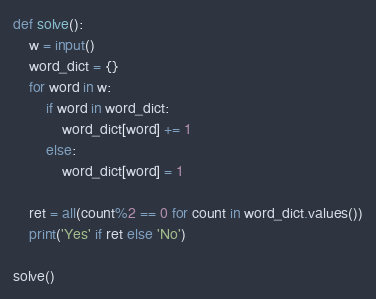<code> <loc_0><loc_0><loc_500><loc_500><_Python_>def solve():
    w = input()
    word_dict = {}
    for word in w:
        if word in word_dict:
            word_dict[word] += 1
        else:
            word_dict[word] = 1
    
    ret = all(count%2 == 0 for count in word_dict.values())
    print('Yes' if ret else 'No')
    
solve()</code> 